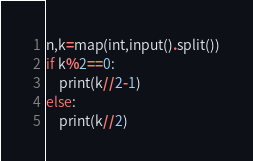Convert code to text. <code><loc_0><loc_0><loc_500><loc_500><_Python_>n,k=map(int,input().split())
if k%2==0:
    print(k//2-1)
else:
    print(k//2)</code> 